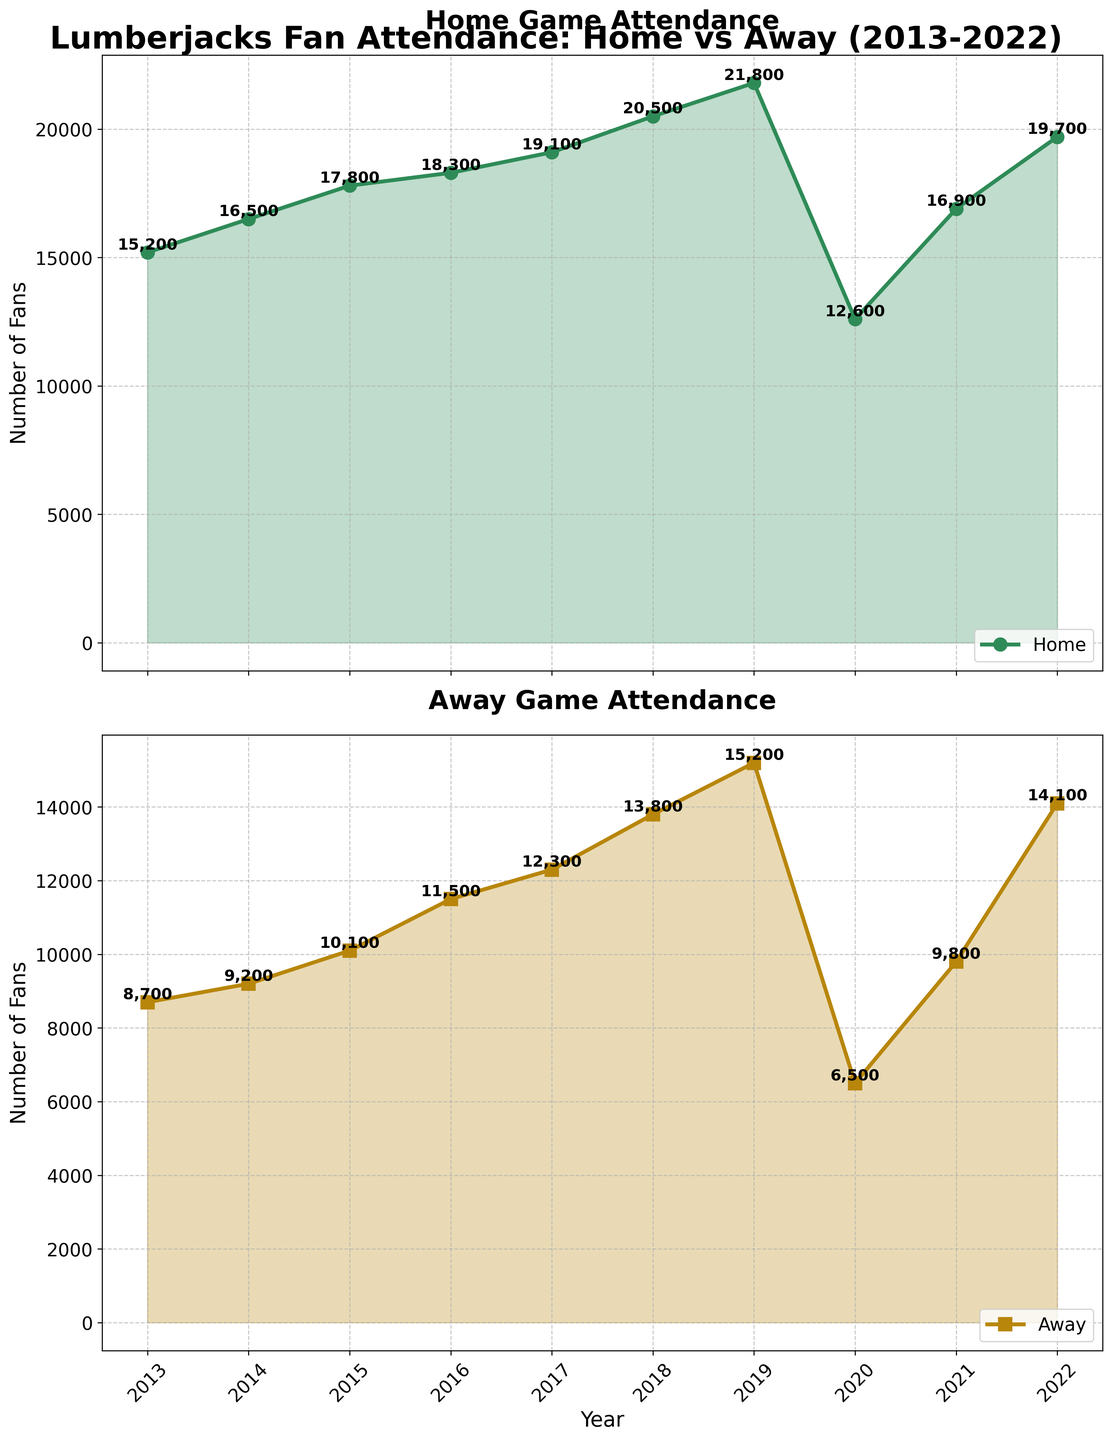what is the title of the figure? The title of the figure is often at the top and provides an overview of the content. Here, it is "Lumberjacks Fan Attendance: Home vs Away (2013-2022)".
Answer: Lumberjacks Fan Attendance: Home vs Away (2013-2022) How many years are covered in the figure? The figure spans from 2013 to 2022, which can be counted from the x-axis labels on both subplots.
Answer: 10 years What was the home attendance in 2016? Look at the data point for the year 2016 on the "Home Game Attendance" subplot. The y-value at this point is 18,300.
Answer: 18,300 Which year had the lowest away attendance and what was that value? By examining the lowest data point in the "Away Game Attendance" subplot, you find that 2020 had the lowest attendance with 6,500 fans.
Answer: 2020, 6,500 Is there a year where both home and away attendance increased significantly when compared to the previous year? Look for a steeper slope in the lines in both subplots. From 2019 to 2021, there is a significant drop and then increase in both home and away attendance. However, from 2018 to 2019, both lines have a noticeable rise. So, the year is 2019 when compared to 2018.
Answer: 2019 When did away attendance surpass 10,000 fans for the first time? Reviewing the "Away Game Attendance" subplot, away attendance surpasses 10,000 fans for the first time in 2015.
Answer: 2015 Which year shows the largest gap between home and away attendance? Calculate the difference (gap) between home and away attendance for each year. The largest difference appears in 2020 with 12,600 (home) - 6,500 (away) = 6,100.
Answer: 2020 How did home attendance trend over the years from 2013 to 2022? Look at the general direction of the home attendance line. Despite a dip in 2020, the overall trend from 2013 to 2022 is an increase.
Answer: Increasing trend What was the average home attendance from 2013 to 2022? Sum up the home attendance values and divide by the number of years: (15200 + 16500 + 17800 + 18300 + 19100 + 20500 + 21800 + 12600 + 16900 + 19700) / 10 = 178900 / 10 = 17,890.
Answer: 17,890 In which years was the home attendance higher than away attendance by more than 7,000 fans? Compare the difference between home and away attendance for each year. The years where the difference is more than 7,000 are 2013 (15200 - 8700 = 6500 does not qualify), 2014 (16500 - 9200 = 7300), and 2020 (12600 - 6500 = 6100 does not qualify). So, only 2014 qualifies.
Answer: 2014 